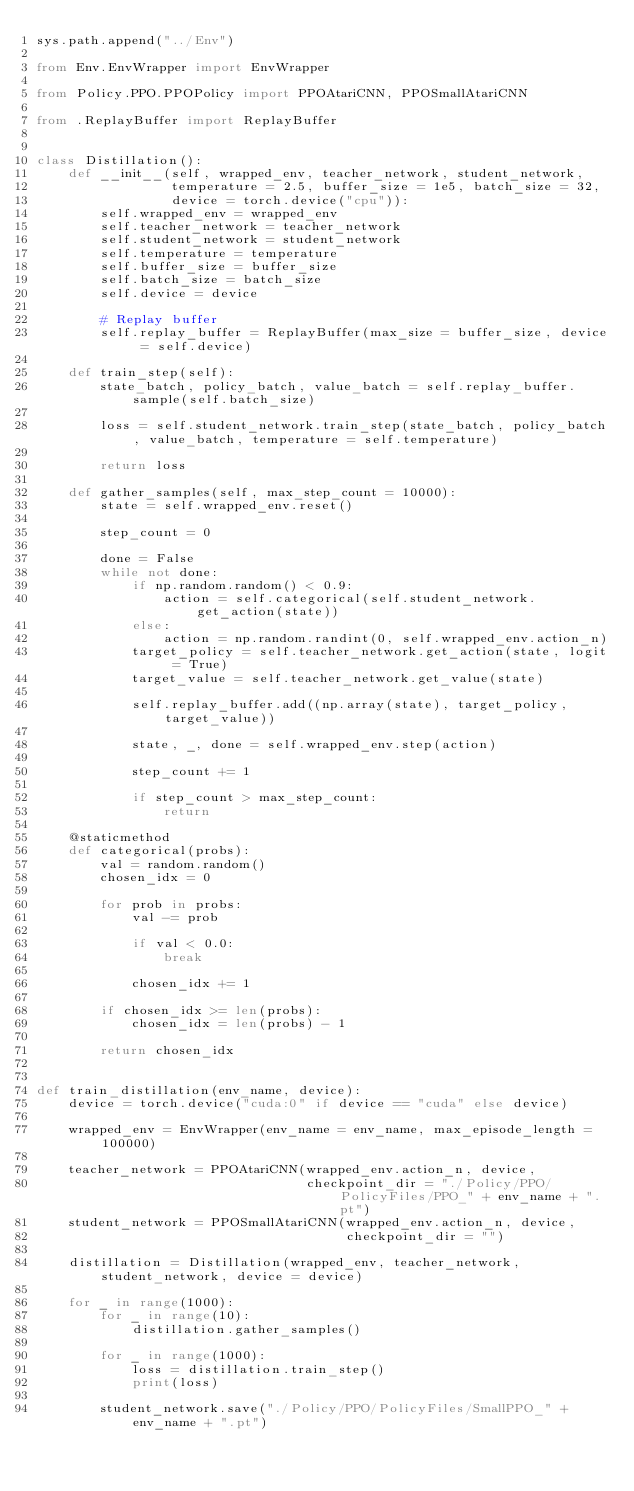Convert code to text. <code><loc_0><loc_0><loc_500><loc_500><_Python_>sys.path.append("../Env")

from Env.EnvWrapper import EnvWrapper

from Policy.PPO.PPOPolicy import PPOAtariCNN, PPOSmallAtariCNN

from .ReplayBuffer import ReplayBuffer


class Distillation():
    def __init__(self, wrapped_env, teacher_network, student_network,
                 temperature = 2.5, buffer_size = 1e5, batch_size = 32,
                 device = torch.device("cpu")):
        self.wrapped_env = wrapped_env
        self.teacher_network = teacher_network
        self.student_network = student_network
        self.temperature = temperature
        self.buffer_size = buffer_size
        self.batch_size = batch_size
        self.device = device

        # Replay buffer
        self.replay_buffer = ReplayBuffer(max_size = buffer_size, device = self.device)

    def train_step(self):
        state_batch, policy_batch, value_batch = self.replay_buffer.sample(self.batch_size)

        loss = self.student_network.train_step(state_batch, policy_batch, value_batch, temperature = self.temperature)

        return loss

    def gather_samples(self, max_step_count = 10000):
        state = self.wrapped_env.reset()

        step_count = 0

        done = False
        while not done:
            if np.random.random() < 0.9:
                action = self.categorical(self.student_network.get_action(state))
            else:
                action = np.random.randint(0, self.wrapped_env.action_n)
            target_policy = self.teacher_network.get_action(state, logit = True)
            target_value = self.teacher_network.get_value(state)

            self.replay_buffer.add((np.array(state), target_policy, target_value))

            state, _, done = self.wrapped_env.step(action)

            step_count += 1

            if step_count > max_step_count:
                return

    @staticmethod
    def categorical(probs):
        val = random.random()
        chosen_idx = 0

        for prob in probs:
            val -= prob

            if val < 0.0:
                break

            chosen_idx += 1

        if chosen_idx >= len(probs):
            chosen_idx = len(probs) - 1

        return chosen_idx


def train_distillation(env_name, device):
    device = torch.device("cuda:0" if device == "cuda" else device)

    wrapped_env = EnvWrapper(env_name = env_name, max_episode_length = 100000)

    teacher_network = PPOAtariCNN(wrapped_env.action_n, device,
                                  checkpoint_dir = "./Policy/PPO/PolicyFiles/PPO_" + env_name + ".pt")
    student_network = PPOSmallAtariCNN(wrapped_env.action_n, device,
                                       checkpoint_dir = "")

    distillation = Distillation(wrapped_env, teacher_network, student_network, device = device)

    for _ in range(1000):
        for _ in range(10):
            distillation.gather_samples()

        for _ in range(1000):
            loss = distillation.train_step()
            print(loss)

        student_network.save("./Policy/PPO/PolicyFiles/SmallPPO_" + env_name + ".pt")
</code> 